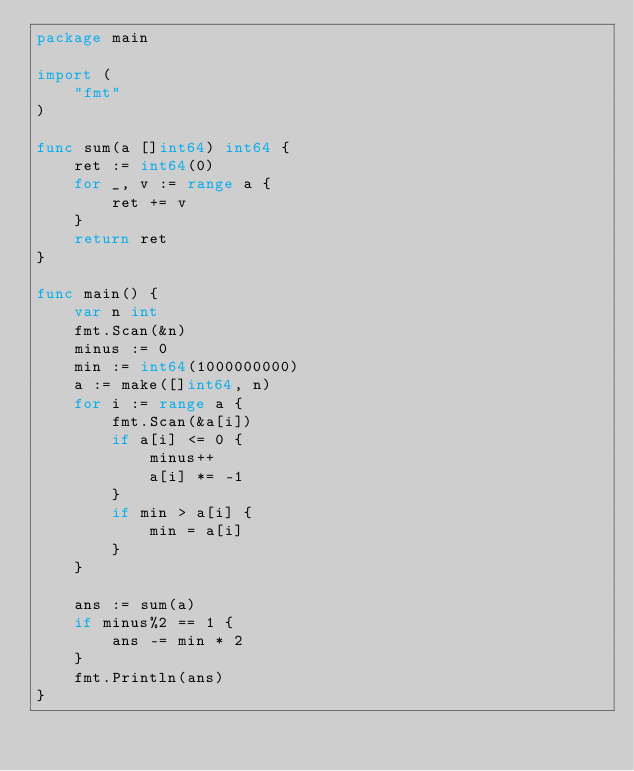Convert code to text. <code><loc_0><loc_0><loc_500><loc_500><_Go_>package main

import (
	"fmt"
)

func sum(a []int64) int64 {
	ret := int64(0)
	for _, v := range a {
		ret += v
	}
	return ret
}

func main() {
	var n int
	fmt.Scan(&n)
	minus := 0
	min := int64(1000000000)
	a := make([]int64, n)
	for i := range a {
		fmt.Scan(&a[i])
		if a[i] <= 0 {
			minus++
			a[i] *= -1
		}
		if min > a[i] {
			min = a[i]
		}
	}

	ans := sum(a)
	if minus%2 == 1 {
		ans -= min * 2
	}
	fmt.Println(ans)
}
</code> 